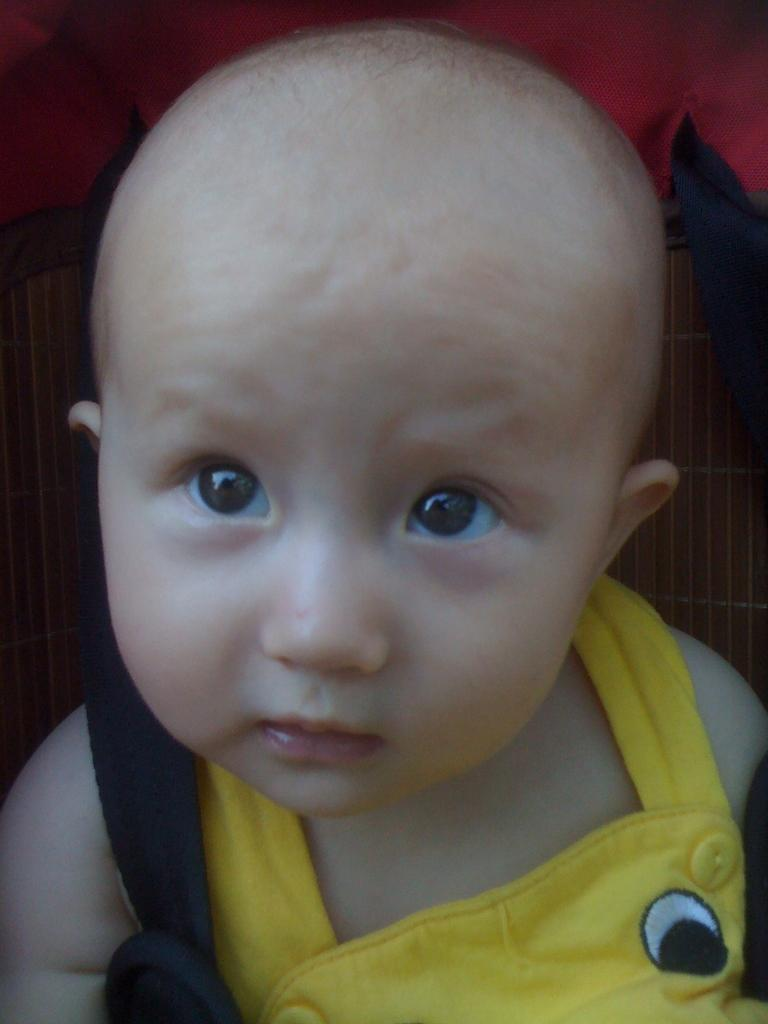What is the main subject of the image? The main subject of the image is a baby. What is the baby doing in the image? The baby is sitting in the image. What is the baby wearing in the image? The baby is wearing a yellow dress in the image. Can you see a snake slithering near the baby in the image? No, there is no snake present in the image. What type of fork is the baby using to eat in the image? There is no fork visible in the image, and the baby is not eating. 